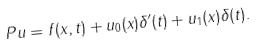Convert formula to latex. <formula><loc_0><loc_0><loc_500><loc_500>P u = f ( x , t ) + u _ { 0 } ( x ) \delta ^ { \prime } ( t ) + u _ { 1 } ( x ) \delta ( t ) .</formula> 